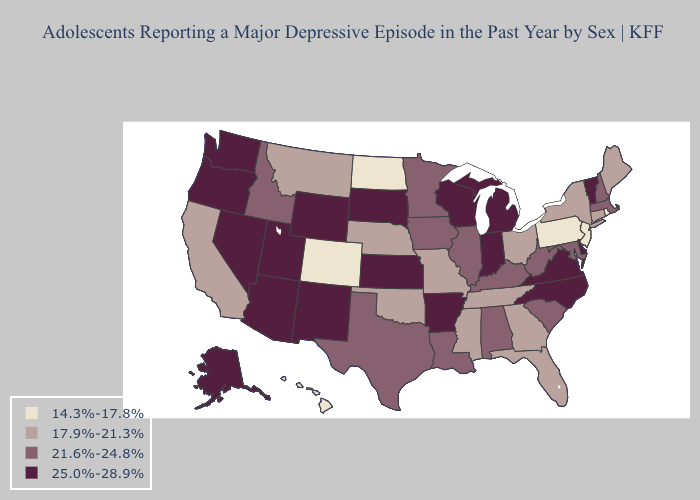Name the states that have a value in the range 25.0%-28.9%?
Answer briefly. Alaska, Arizona, Arkansas, Delaware, Indiana, Kansas, Michigan, Nevada, New Mexico, North Carolina, Oregon, South Dakota, Utah, Vermont, Virginia, Washington, Wisconsin, Wyoming. What is the lowest value in the Northeast?
Write a very short answer. 14.3%-17.8%. Does Massachusetts have the lowest value in the USA?
Give a very brief answer. No. Name the states that have a value in the range 14.3%-17.8%?
Give a very brief answer. Colorado, Hawaii, New Jersey, North Dakota, Pennsylvania, Rhode Island. What is the highest value in the South ?
Concise answer only. 25.0%-28.9%. What is the value of Oklahoma?
Quick response, please. 17.9%-21.3%. Name the states that have a value in the range 17.9%-21.3%?
Write a very short answer. California, Connecticut, Florida, Georgia, Maine, Mississippi, Missouri, Montana, Nebraska, New York, Ohio, Oklahoma, Tennessee. Does Indiana have the highest value in the USA?
Quick response, please. Yes. Which states have the lowest value in the USA?
Answer briefly. Colorado, Hawaii, New Jersey, North Dakota, Pennsylvania, Rhode Island. Name the states that have a value in the range 25.0%-28.9%?
Concise answer only. Alaska, Arizona, Arkansas, Delaware, Indiana, Kansas, Michigan, Nevada, New Mexico, North Carolina, Oregon, South Dakota, Utah, Vermont, Virginia, Washington, Wisconsin, Wyoming. What is the value of Georgia?
Quick response, please. 17.9%-21.3%. What is the highest value in the Northeast ?
Give a very brief answer. 25.0%-28.9%. What is the value of Louisiana?
Quick response, please. 21.6%-24.8%. What is the highest value in states that border Rhode Island?
Give a very brief answer. 21.6%-24.8%. Name the states that have a value in the range 17.9%-21.3%?
Answer briefly. California, Connecticut, Florida, Georgia, Maine, Mississippi, Missouri, Montana, Nebraska, New York, Ohio, Oklahoma, Tennessee. 